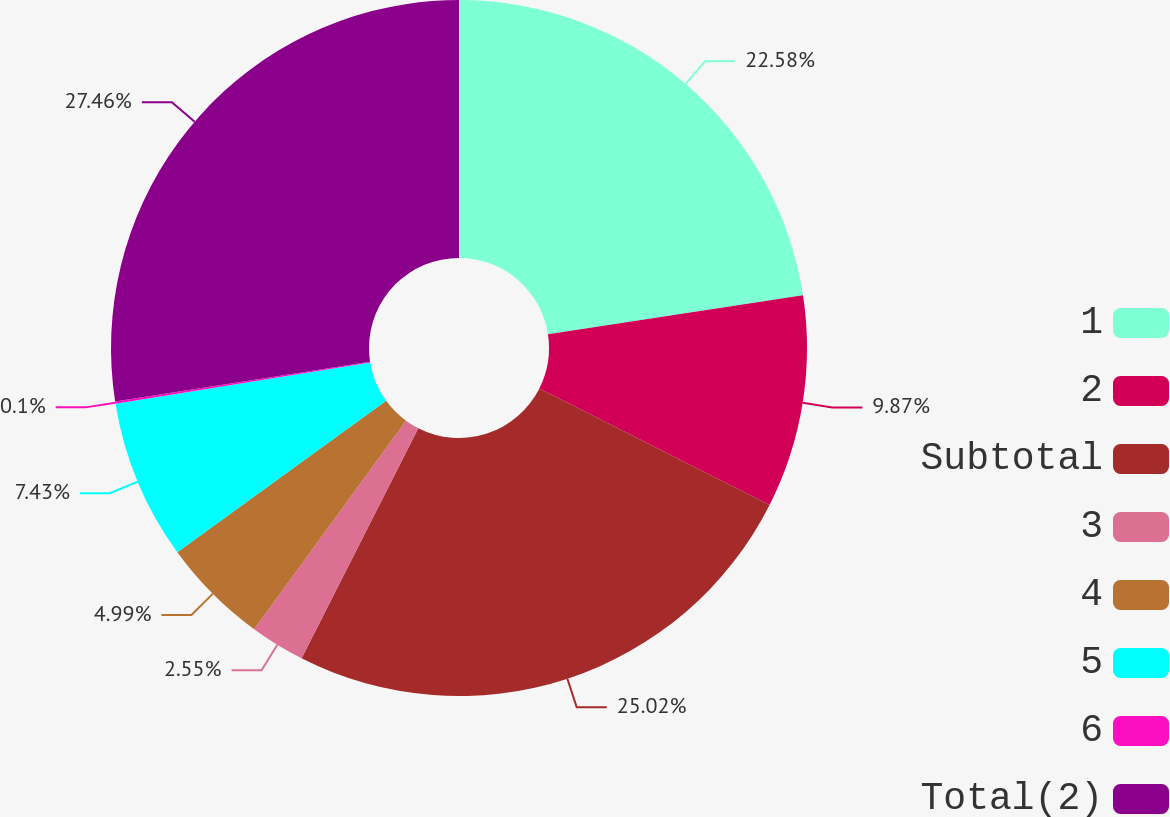Convert chart to OTSL. <chart><loc_0><loc_0><loc_500><loc_500><pie_chart><fcel>1<fcel>2<fcel>Subtotal<fcel>3<fcel>4<fcel>5<fcel>6<fcel>Total(2)<nl><fcel>22.58%<fcel>9.87%<fcel>25.02%<fcel>2.55%<fcel>4.99%<fcel>7.43%<fcel>0.1%<fcel>27.46%<nl></chart> 